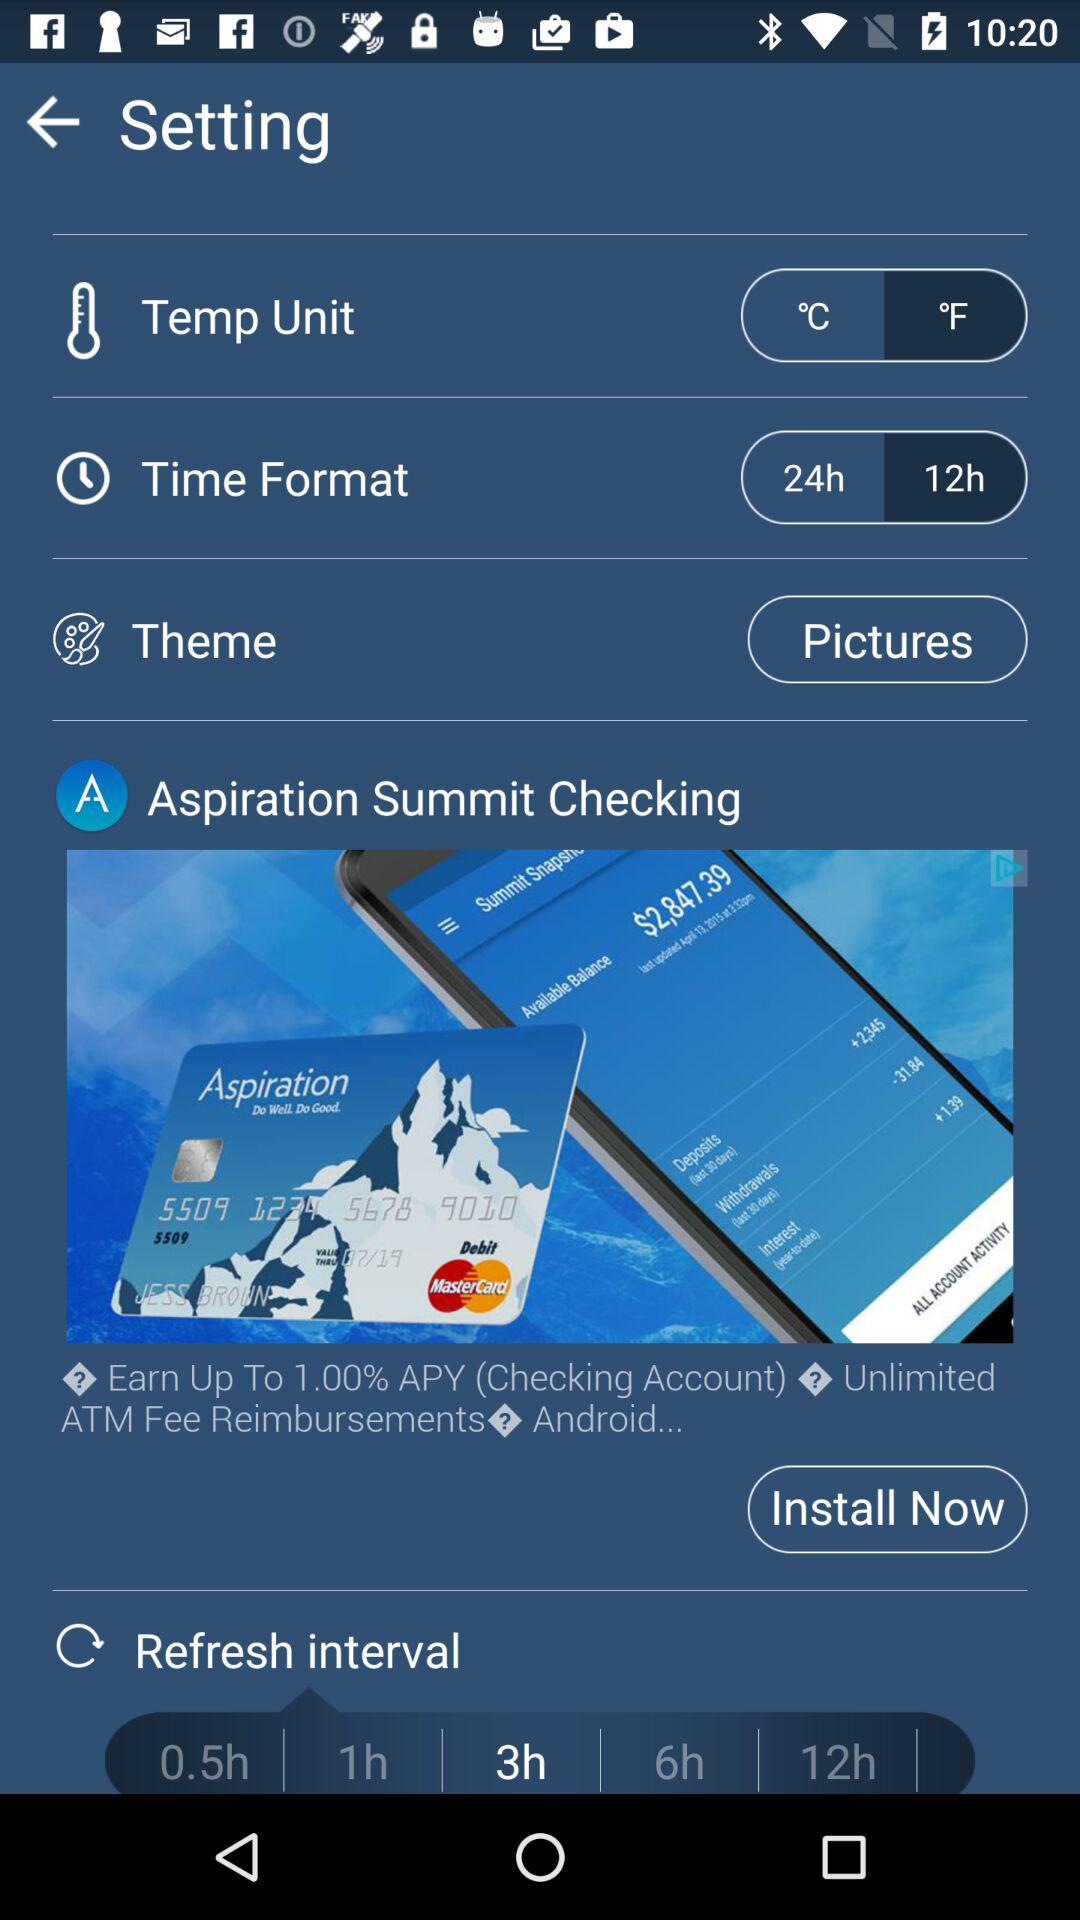What is the selected unit of temperature? The selected unit of temperature is "°F". 